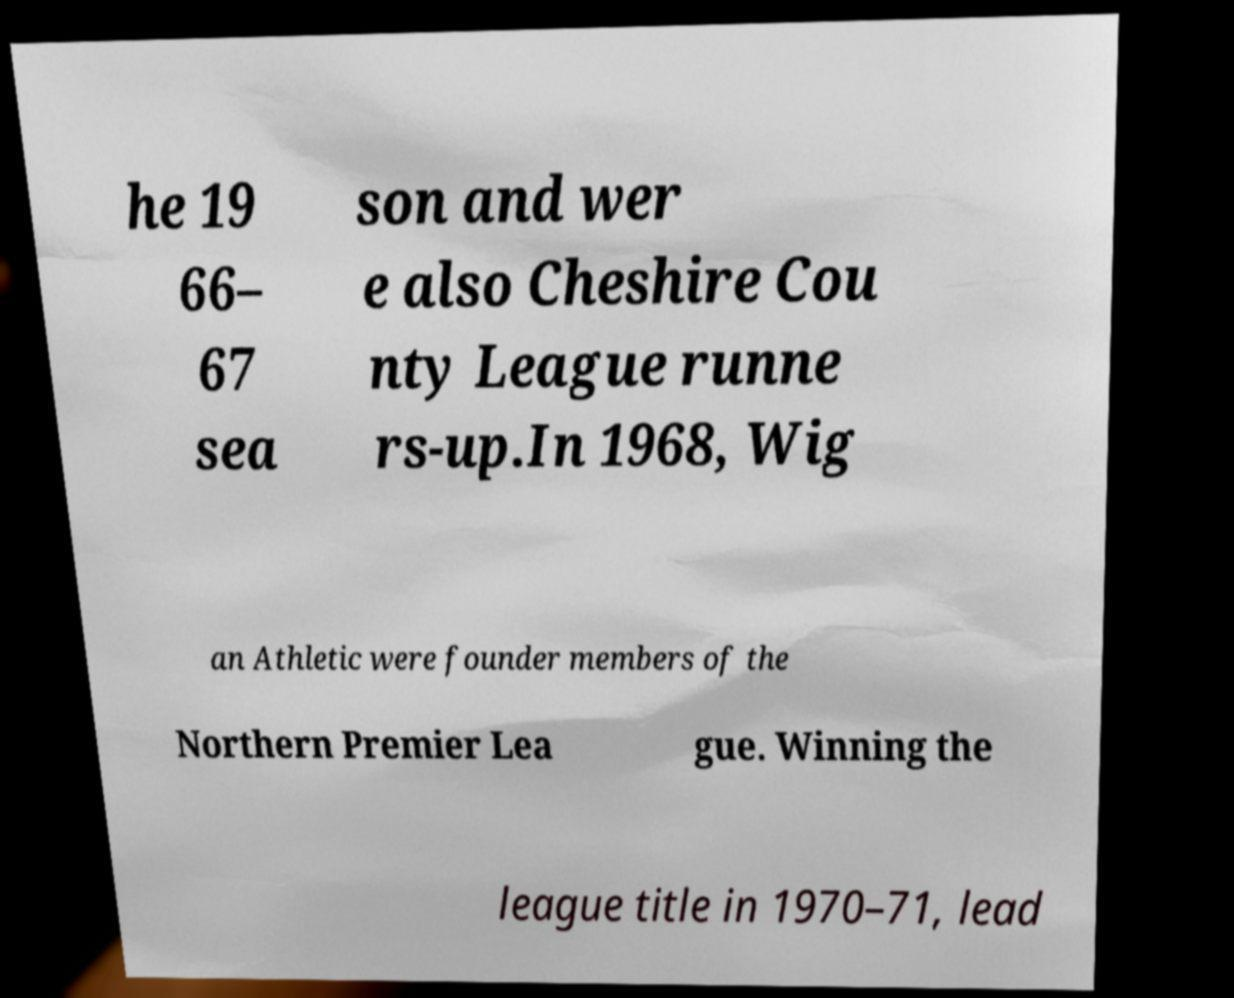Can you read and provide the text displayed in the image?This photo seems to have some interesting text. Can you extract and type it out for me? he 19 66– 67 sea son and wer e also Cheshire Cou nty League runne rs-up.In 1968, Wig an Athletic were founder members of the Northern Premier Lea gue. Winning the league title in 1970–71, lead 